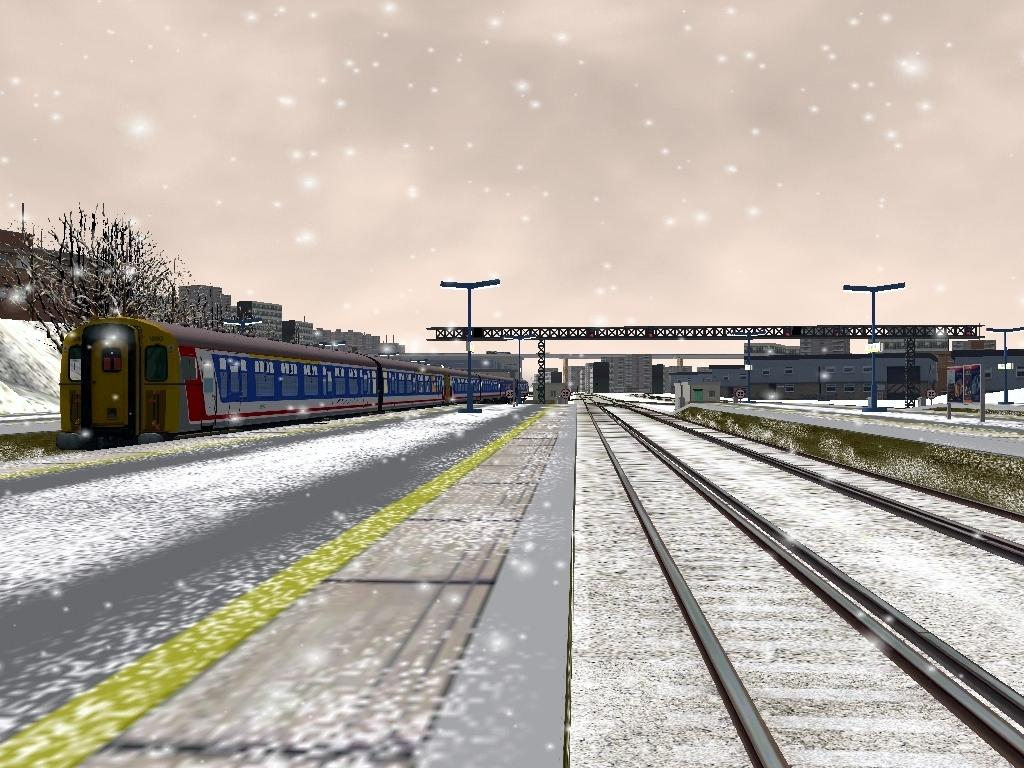What is located on the left side of the image? There is a train on the left side of the image. What is the train situated on? The train is on a railway track. What can be seen on the right side of the image? There are railway tracks on the right side of the image. What is visible in the background of the image? There are poles, buildings, and clouds in the sky in the background of the image. What month is it in the image? The month cannot be determined from the image, as there is no information about the date or time of year. 